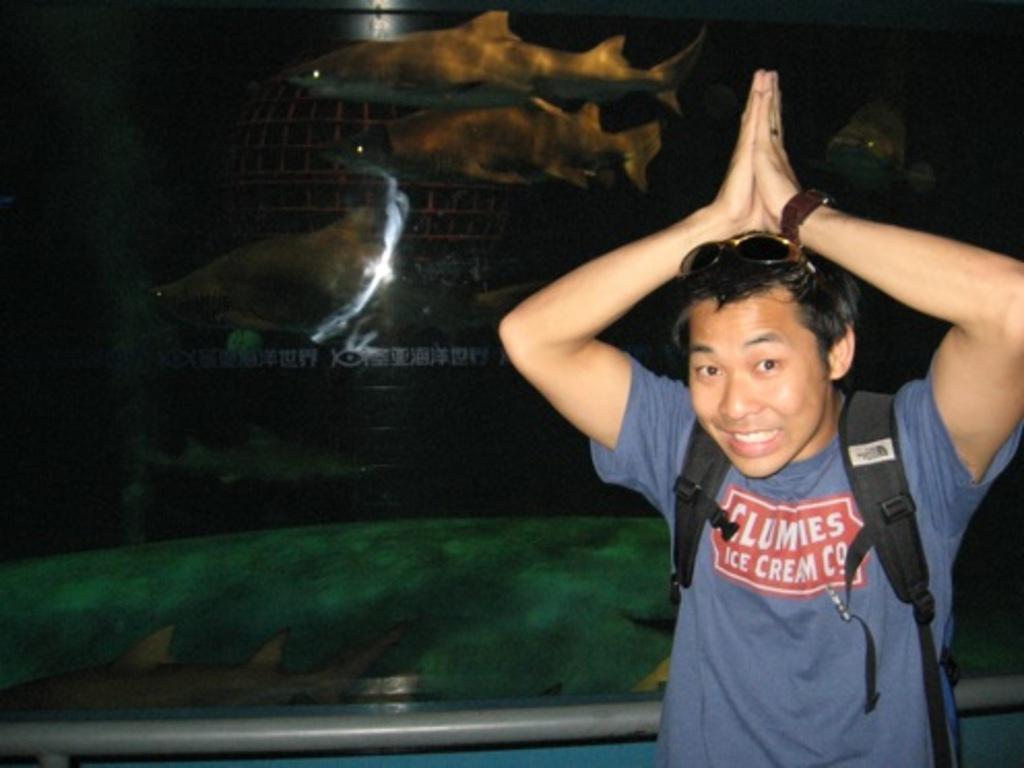Please provide a concise description of this image. In the image a man is standing and smiling. Behind him there is glass and there are some fishes. 